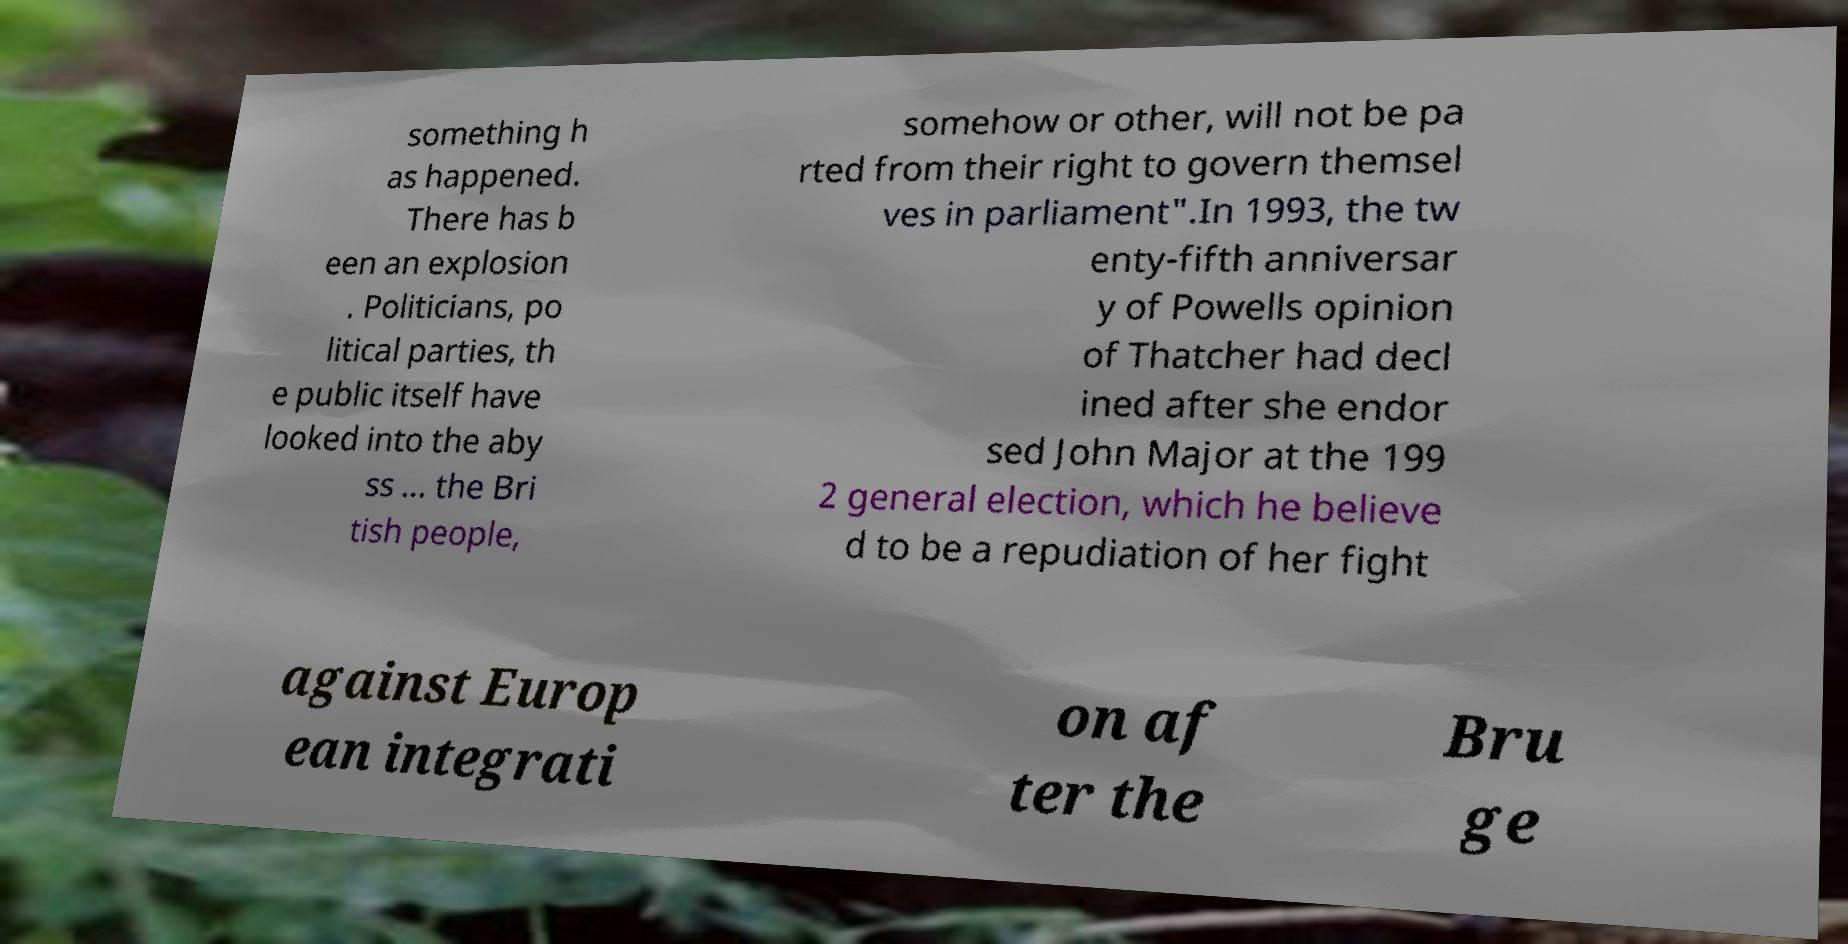Can you read and provide the text displayed in the image?This photo seems to have some interesting text. Can you extract and type it out for me? something h as happened. There has b een an explosion . Politicians, po litical parties, th e public itself have looked into the aby ss ... the Bri tish people, somehow or other, will not be pa rted from their right to govern themsel ves in parliament".In 1993, the tw enty-fifth anniversar y of Powells opinion of Thatcher had decl ined after she endor sed John Major at the 199 2 general election, which he believe d to be a repudiation of her fight against Europ ean integrati on af ter the Bru ge 